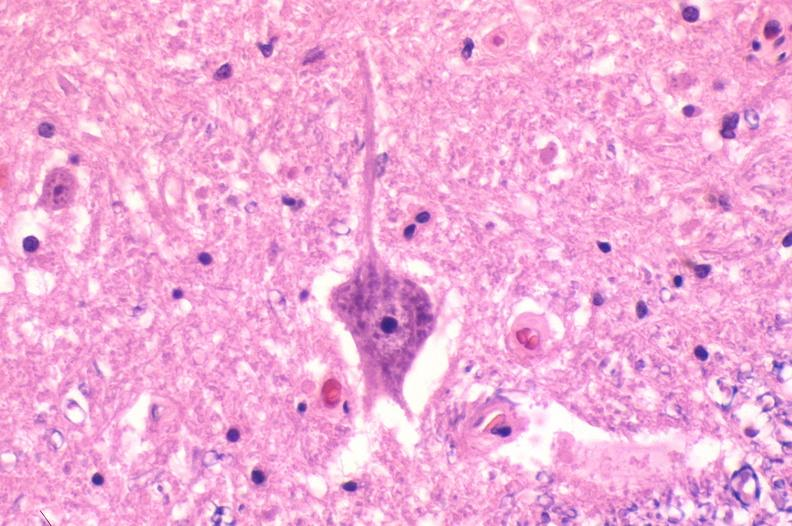why does this image show spinal cord injury?
Answer the question using a single word or phrase. Due to vertebral column trauma 